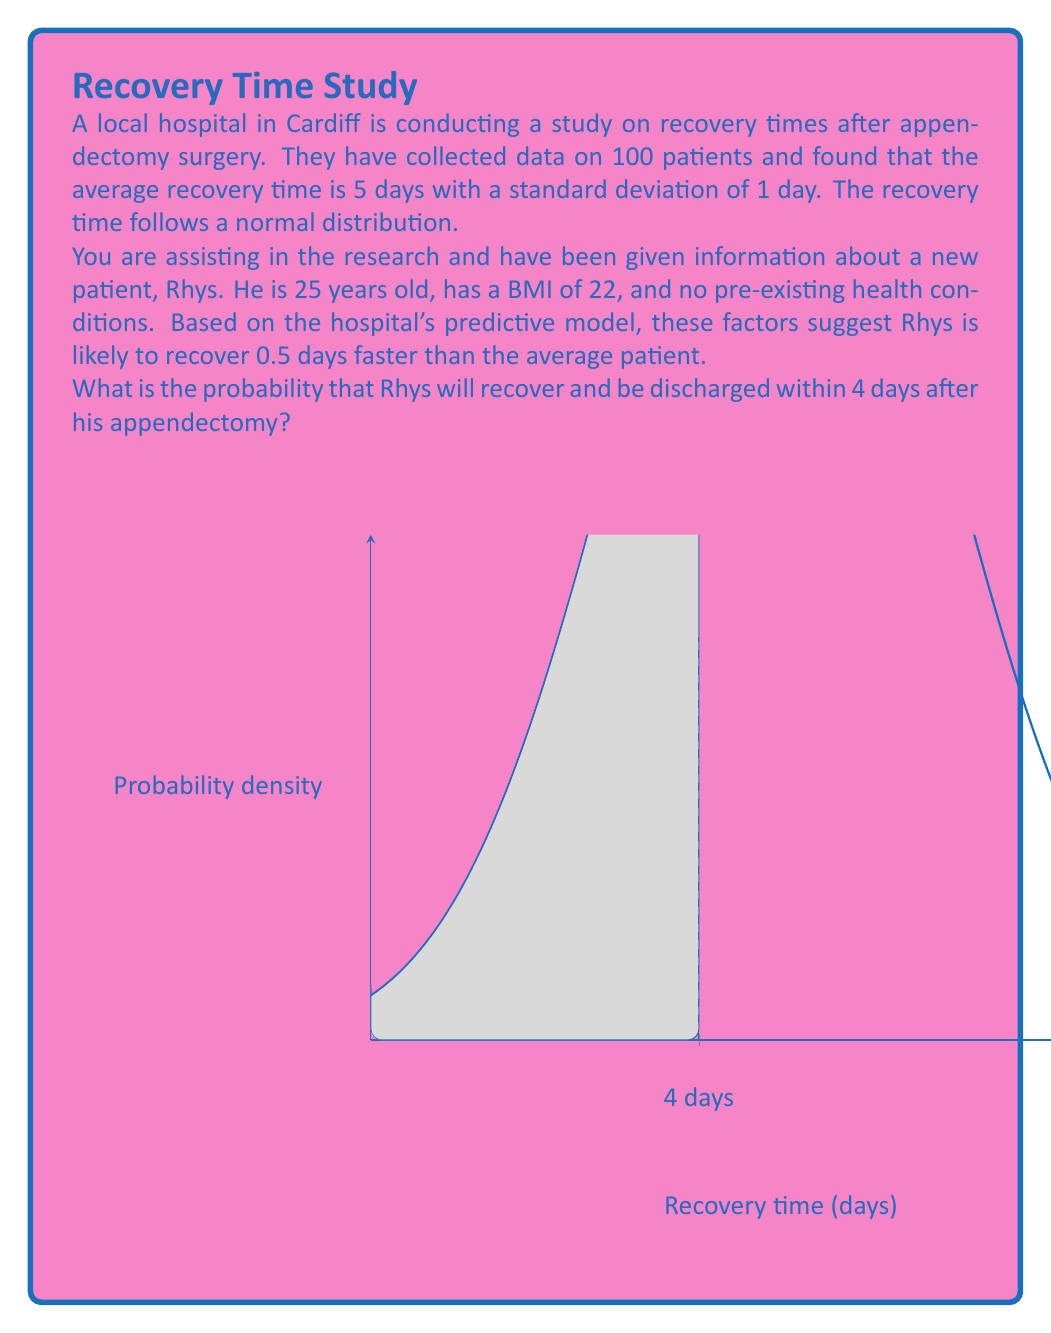Provide a solution to this math problem. Let's approach this step-by-step using Bayesian statistics:

1) We're given that the average recovery time is 5 days with a standard deviation of 1 day, and it follows a normal distribution.

2) Rhys is expected to recover 0.5 days faster than average, so his expected recovery time is:
   $$\mu_{\text{Rhys}} = 5 - 0.5 = 4.5 \text{ days}$$

3) We assume the standard deviation remains the same at 1 day.

4) We want to find the probability that Rhys recovers within 4 days. In statistical terms, we need to find:
   $$P(X \leq 4)$$
   where $X$ is Rhys's recovery time.

5) To solve this, we need to calculate the z-score for 4 days:
   $$z = \frac{x - \mu}{\sigma} = \frac{4 - 4.5}{1} = -0.5$$

6) Now we need to find the probability of $Z \leq -0.5$ using a standard normal distribution table or calculator.

7) Using a standard normal distribution table or calculator, we find:
   $$P(Z \leq -0.5) \approx 0.3085$$

Therefore, the probability that Rhys will recover and be discharged within 4 days after his appendectomy is approximately 0.3085 or 30.85%.
Answer: $0.3085$ or $30.85\%$ 